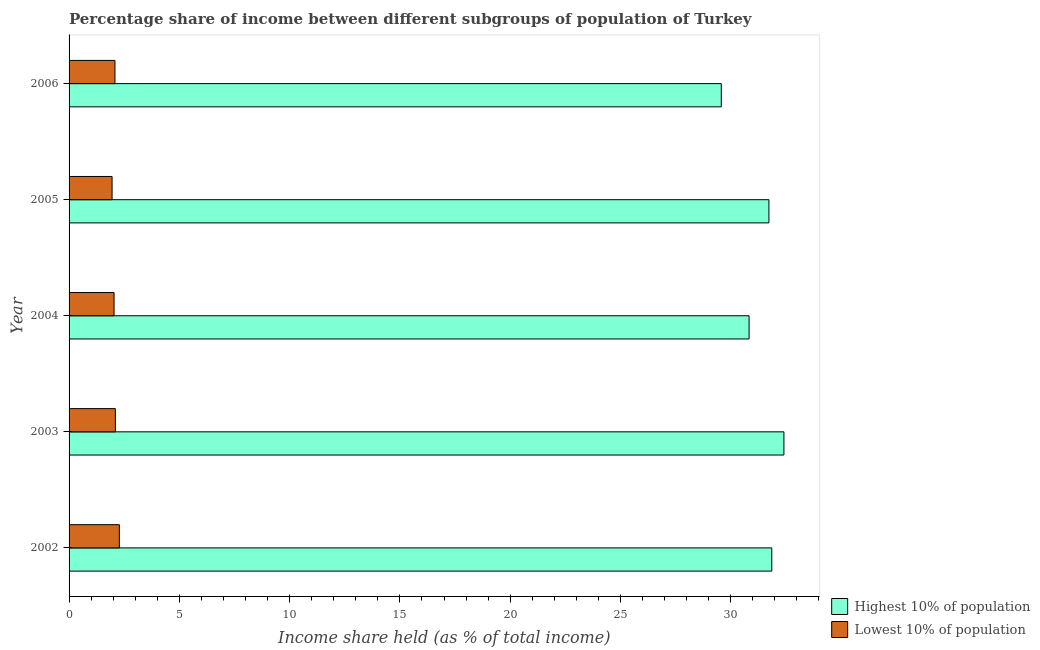How many groups of bars are there?
Your answer should be very brief. 5. Are the number of bars on each tick of the Y-axis equal?
Your answer should be compact. Yes. How many bars are there on the 5th tick from the top?
Keep it short and to the point. 2. How many bars are there on the 3rd tick from the bottom?
Your response must be concise. 2. What is the label of the 3rd group of bars from the top?
Offer a terse response. 2004. What is the income share held by highest 10% of the population in 2002?
Your answer should be very brief. 31.86. Across all years, what is the maximum income share held by lowest 10% of the population?
Keep it short and to the point. 2.28. Across all years, what is the minimum income share held by highest 10% of the population?
Make the answer very short. 29.57. In which year was the income share held by highest 10% of the population maximum?
Keep it short and to the point. 2003. What is the total income share held by highest 10% of the population in the graph?
Give a very brief answer. 156.4. What is the difference between the income share held by lowest 10% of the population in 2003 and the income share held by highest 10% of the population in 2006?
Make the answer very short. -27.47. What is the average income share held by lowest 10% of the population per year?
Provide a short and direct response. 2.09. In the year 2004, what is the difference between the income share held by highest 10% of the population and income share held by lowest 10% of the population?
Give a very brief answer. 28.79. What is the ratio of the income share held by lowest 10% of the population in 2003 to that in 2004?
Ensure brevity in your answer.  1.03. Is the income share held by lowest 10% of the population in 2002 less than that in 2005?
Your answer should be compact. No. Is the difference between the income share held by lowest 10% of the population in 2004 and 2006 greater than the difference between the income share held by highest 10% of the population in 2004 and 2006?
Offer a terse response. No. What is the difference between the highest and the second highest income share held by highest 10% of the population?
Keep it short and to the point. 0.55. What is the difference between the highest and the lowest income share held by lowest 10% of the population?
Make the answer very short. 0.33. What does the 1st bar from the top in 2005 represents?
Your answer should be compact. Lowest 10% of population. What does the 1st bar from the bottom in 2006 represents?
Your response must be concise. Highest 10% of population. How many bars are there?
Provide a short and direct response. 10. Are the values on the major ticks of X-axis written in scientific E-notation?
Give a very brief answer. No. Does the graph contain any zero values?
Offer a terse response. No. Does the graph contain grids?
Make the answer very short. No. Where does the legend appear in the graph?
Your response must be concise. Bottom right. What is the title of the graph?
Offer a very short reply. Percentage share of income between different subgroups of population of Turkey. Does "Mobile cellular" appear as one of the legend labels in the graph?
Ensure brevity in your answer.  No. What is the label or title of the X-axis?
Your answer should be compact. Income share held (as % of total income). What is the Income share held (as % of total income) in Highest 10% of population in 2002?
Make the answer very short. 31.86. What is the Income share held (as % of total income) in Lowest 10% of population in 2002?
Provide a succinct answer. 2.28. What is the Income share held (as % of total income) of Highest 10% of population in 2003?
Give a very brief answer. 32.41. What is the Income share held (as % of total income) in Lowest 10% of population in 2003?
Make the answer very short. 2.1. What is the Income share held (as % of total income) in Highest 10% of population in 2004?
Offer a very short reply. 30.83. What is the Income share held (as % of total income) in Lowest 10% of population in 2004?
Provide a short and direct response. 2.04. What is the Income share held (as % of total income) of Highest 10% of population in 2005?
Make the answer very short. 31.73. What is the Income share held (as % of total income) in Lowest 10% of population in 2005?
Make the answer very short. 1.95. What is the Income share held (as % of total income) in Highest 10% of population in 2006?
Keep it short and to the point. 29.57. What is the Income share held (as % of total income) in Lowest 10% of population in 2006?
Give a very brief answer. 2.08. Across all years, what is the maximum Income share held (as % of total income) of Highest 10% of population?
Ensure brevity in your answer.  32.41. Across all years, what is the maximum Income share held (as % of total income) in Lowest 10% of population?
Your response must be concise. 2.28. Across all years, what is the minimum Income share held (as % of total income) in Highest 10% of population?
Ensure brevity in your answer.  29.57. Across all years, what is the minimum Income share held (as % of total income) of Lowest 10% of population?
Provide a short and direct response. 1.95. What is the total Income share held (as % of total income) of Highest 10% of population in the graph?
Make the answer very short. 156.4. What is the total Income share held (as % of total income) of Lowest 10% of population in the graph?
Your answer should be very brief. 10.45. What is the difference between the Income share held (as % of total income) in Highest 10% of population in 2002 and that in 2003?
Ensure brevity in your answer.  -0.55. What is the difference between the Income share held (as % of total income) in Lowest 10% of population in 2002 and that in 2003?
Provide a short and direct response. 0.18. What is the difference between the Income share held (as % of total income) of Highest 10% of population in 2002 and that in 2004?
Your response must be concise. 1.03. What is the difference between the Income share held (as % of total income) in Lowest 10% of population in 2002 and that in 2004?
Ensure brevity in your answer.  0.24. What is the difference between the Income share held (as % of total income) of Highest 10% of population in 2002 and that in 2005?
Make the answer very short. 0.13. What is the difference between the Income share held (as % of total income) of Lowest 10% of population in 2002 and that in 2005?
Offer a terse response. 0.33. What is the difference between the Income share held (as % of total income) of Highest 10% of population in 2002 and that in 2006?
Your answer should be very brief. 2.29. What is the difference between the Income share held (as % of total income) in Highest 10% of population in 2003 and that in 2004?
Provide a short and direct response. 1.58. What is the difference between the Income share held (as % of total income) of Lowest 10% of population in 2003 and that in 2004?
Offer a very short reply. 0.06. What is the difference between the Income share held (as % of total income) in Highest 10% of population in 2003 and that in 2005?
Provide a succinct answer. 0.68. What is the difference between the Income share held (as % of total income) in Lowest 10% of population in 2003 and that in 2005?
Your response must be concise. 0.15. What is the difference between the Income share held (as % of total income) of Highest 10% of population in 2003 and that in 2006?
Give a very brief answer. 2.84. What is the difference between the Income share held (as % of total income) in Lowest 10% of population in 2003 and that in 2006?
Give a very brief answer. 0.02. What is the difference between the Income share held (as % of total income) in Highest 10% of population in 2004 and that in 2005?
Your answer should be very brief. -0.9. What is the difference between the Income share held (as % of total income) in Lowest 10% of population in 2004 and that in 2005?
Your answer should be very brief. 0.09. What is the difference between the Income share held (as % of total income) of Highest 10% of population in 2004 and that in 2006?
Provide a succinct answer. 1.26. What is the difference between the Income share held (as % of total income) of Lowest 10% of population in 2004 and that in 2006?
Provide a short and direct response. -0.04. What is the difference between the Income share held (as % of total income) of Highest 10% of population in 2005 and that in 2006?
Offer a very short reply. 2.16. What is the difference between the Income share held (as % of total income) of Lowest 10% of population in 2005 and that in 2006?
Provide a succinct answer. -0.13. What is the difference between the Income share held (as % of total income) of Highest 10% of population in 2002 and the Income share held (as % of total income) of Lowest 10% of population in 2003?
Make the answer very short. 29.76. What is the difference between the Income share held (as % of total income) in Highest 10% of population in 2002 and the Income share held (as % of total income) in Lowest 10% of population in 2004?
Make the answer very short. 29.82. What is the difference between the Income share held (as % of total income) in Highest 10% of population in 2002 and the Income share held (as % of total income) in Lowest 10% of population in 2005?
Your answer should be compact. 29.91. What is the difference between the Income share held (as % of total income) in Highest 10% of population in 2002 and the Income share held (as % of total income) in Lowest 10% of population in 2006?
Keep it short and to the point. 29.78. What is the difference between the Income share held (as % of total income) of Highest 10% of population in 2003 and the Income share held (as % of total income) of Lowest 10% of population in 2004?
Make the answer very short. 30.37. What is the difference between the Income share held (as % of total income) of Highest 10% of population in 2003 and the Income share held (as % of total income) of Lowest 10% of population in 2005?
Give a very brief answer. 30.46. What is the difference between the Income share held (as % of total income) of Highest 10% of population in 2003 and the Income share held (as % of total income) of Lowest 10% of population in 2006?
Your answer should be compact. 30.33. What is the difference between the Income share held (as % of total income) of Highest 10% of population in 2004 and the Income share held (as % of total income) of Lowest 10% of population in 2005?
Provide a short and direct response. 28.88. What is the difference between the Income share held (as % of total income) of Highest 10% of population in 2004 and the Income share held (as % of total income) of Lowest 10% of population in 2006?
Your answer should be compact. 28.75. What is the difference between the Income share held (as % of total income) in Highest 10% of population in 2005 and the Income share held (as % of total income) in Lowest 10% of population in 2006?
Ensure brevity in your answer.  29.65. What is the average Income share held (as % of total income) in Highest 10% of population per year?
Offer a terse response. 31.28. What is the average Income share held (as % of total income) of Lowest 10% of population per year?
Give a very brief answer. 2.09. In the year 2002, what is the difference between the Income share held (as % of total income) of Highest 10% of population and Income share held (as % of total income) of Lowest 10% of population?
Provide a short and direct response. 29.58. In the year 2003, what is the difference between the Income share held (as % of total income) of Highest 10% of population and Income share held (as % of total income) of Lowest 10% of population?
Provide a short and direct response. 30.31. In the year 2004, what is the difference between the Income share held (as % of total income) in Highest 10% of population and Income share held (as % of total income) in Lowest 10% of population?
Offer a terse response. 28.79. In the year 2005, what is the difference between the Income share held (as % of total income) of Highest 10% of population and Income share held (as % of total income) of Lowest 10% of population?
Offer a very short reply. 29.78. In the year 2006, what is the difference between the Income share held (as % of total income) in Highest 10% of population and Income share held (as % of total income) in Lowest 10% of population?
Give a very brief answer. 27.49. What is the ratio of the Income share held (as % of total income) of Highest 10% of population in 2002 to that in 2003?
Give a very brief answer. 0.98. What is the ratio of the Income share held (as % of total income) in Lowest 10% of population in 2002 to that in 2003?
Your answer should be very brief. 1.09. What is the ratio of the Income share held (as % of total income) of Highest 10% of population in 2002 to that in 2004?
Your answer should be very brief. 1.03. What is the ratio of the Income share held (as % of total income) in Lowest 10% of population in 2002 to that in 2004?
Keep it short and to the point. 1.12. What is the ratio of the Income share held (as % of total income) of Highest 10% of population in 2002 to that in 2005?
Provide a succinct answer. 1. What is the ratio of the Income share held (as % of total income) of Lowest 10% of population in 2002 to that in 2005?
Provide a succinct answer. 1.17. What is the ratio of the Income share held (as % of total income) of Highest 10% of population in 2002 to that in 2006?
Keep it short and to the point. 1.08. What is the ratio of the Income share held (as % of total income) in Lowest 10% of population in 2002 to that in 2006?
Make the answer very short. 1.1. What is the ratio of the Income share held (as % of total income) of Highest 10% of population in 2003 to that in 2004?
Your answer should be very brief. 1.05. What is the ratio of the Income share held (as % of total income) of Lowest 10% of population in 2003 to that in 2004?
Your response must be concise. 1.03. What is the ratio of the Income share held (as % of total income) of Highest 10% of population in 2003 to that in 2005?
Provide a succinct answer. 1.02. What is the ratio of the Income share held (as % of total income) in Highest 10% of population in 2003 to that in 2006?
Offer a very short reply. 1.1. What is the ratio of the Income share held (as % of total income) of Lowest 10% of population in 2003 to that in 2006?
Keep it short and to the point. 1.01. What is the ratio of the Income share held (as % of total income) in Highest 10% of population in 2004 to that in 2005?
Offer a terse response. 0.97. What is the ratio of the Income share held (as % of total income) in Lowest 10% of population in 2004 to that in 2005?
Your answer should be compact. 1.05. What is the ratio of the Income share held (as % of total income) in Highest 10% of population in 2004 to that in 2006?
Provide a short and direct response. 1.04. What is the ratio of the Income share held (as % of total income) in Lowest 10% of population in 2004 to that in 2006?
Ensure brevity in your answer.  0.98. What is the ratio of the Income share held (as % of total income) of Highest 10% of population in 2005 to that in 2006?
Your answer should be very brief. 1.07. What is the ratio of the Income share held (as % of total income) of Lowest 10% of population in 2005 to that in 2006?
Give a very brief answer. 0.94. What is the difference between the highest and the second highest Income share held (as % of total income) in Highest 10% of population?
Provide a succinct answer. 0.55. What is the difference between the highest and the second highest Income share held (as % of total income) of Lowest 10% of population?
Keep it short and to the point. 0.18. What is the difference between the highest and the lowest Income share held (as % of total income) in Highest 10% of population?
Make the answer very short. 2.84. What is the difference between the highest and the lowest Income share held (as % of total income) of Lowest 10% of population?
Give a very brief answer. 0.33. 